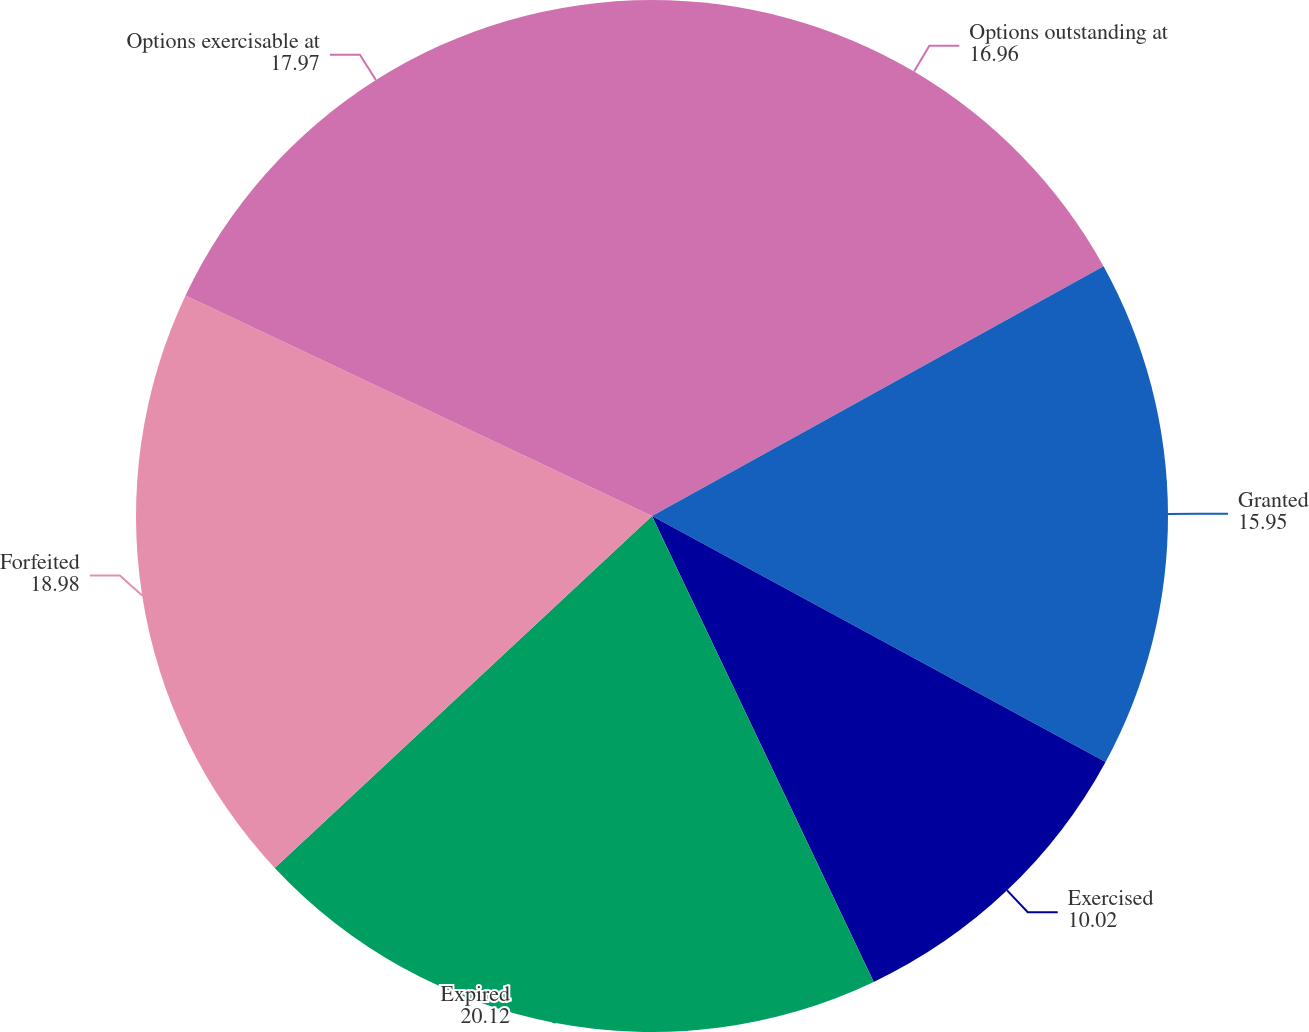<chart> <loc_0><loc_0><loc_500><loc_500><pie_chart><fcel>Options outstanding at<fcel>Granted<fcel>Exercised<fcel>Expired<fcel>Forfeited<fcel>Options exercisable at<nl><fcel>16.96%<fcel>15.95%<fcel>10.02%<fcel>20.12%<fcel>18.98%<fcel>17.97%<nl></chart> 